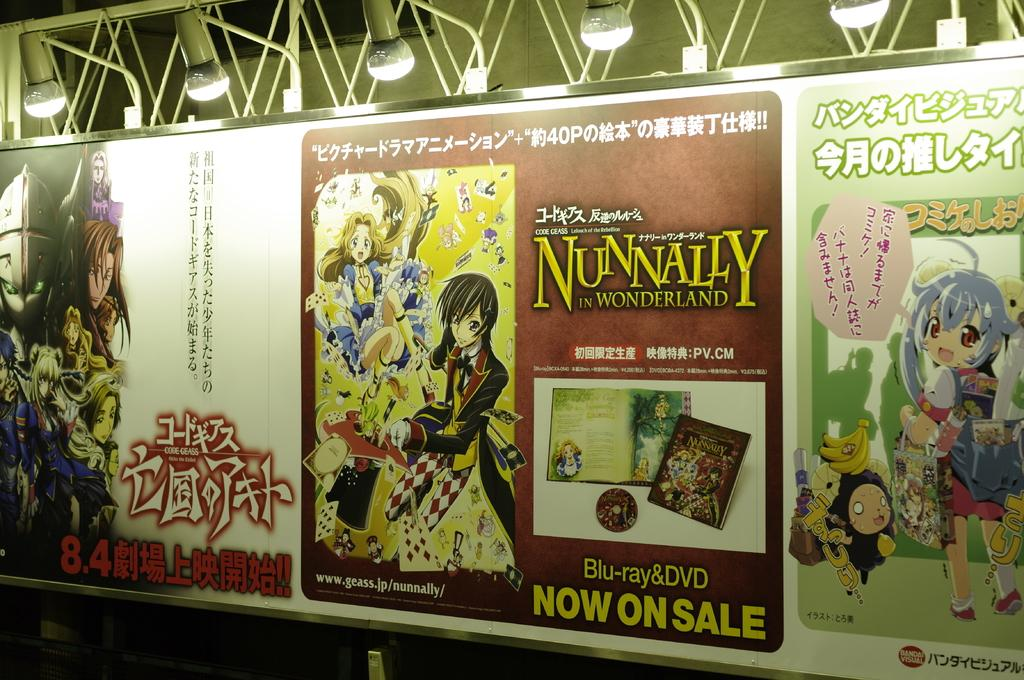<image>
Relay a brief, clear account of the picture shown. Three anime posters including one for Nunnally in Wonderland. 